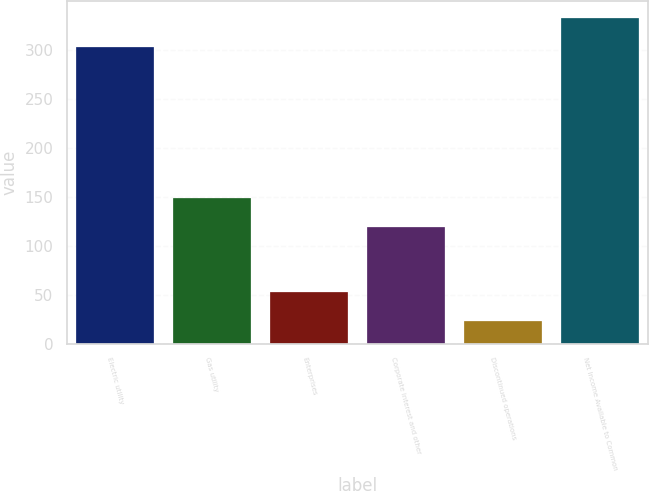Convert chart to OTSL. <chart><loc_0><loc_0><loc_500><loc_500><bar_chart><fcel>Electric utility<fcel>Gas utility<fcel>Enterprises<fcel>Corporate interest and other<fcel>Discontinued operations<fcel>Net Income Available to Common<nl><fcel>303<fcel>149.1<fcel>53.1<fcel>119<fcel>23<fcel>333.1<nl></chart> 